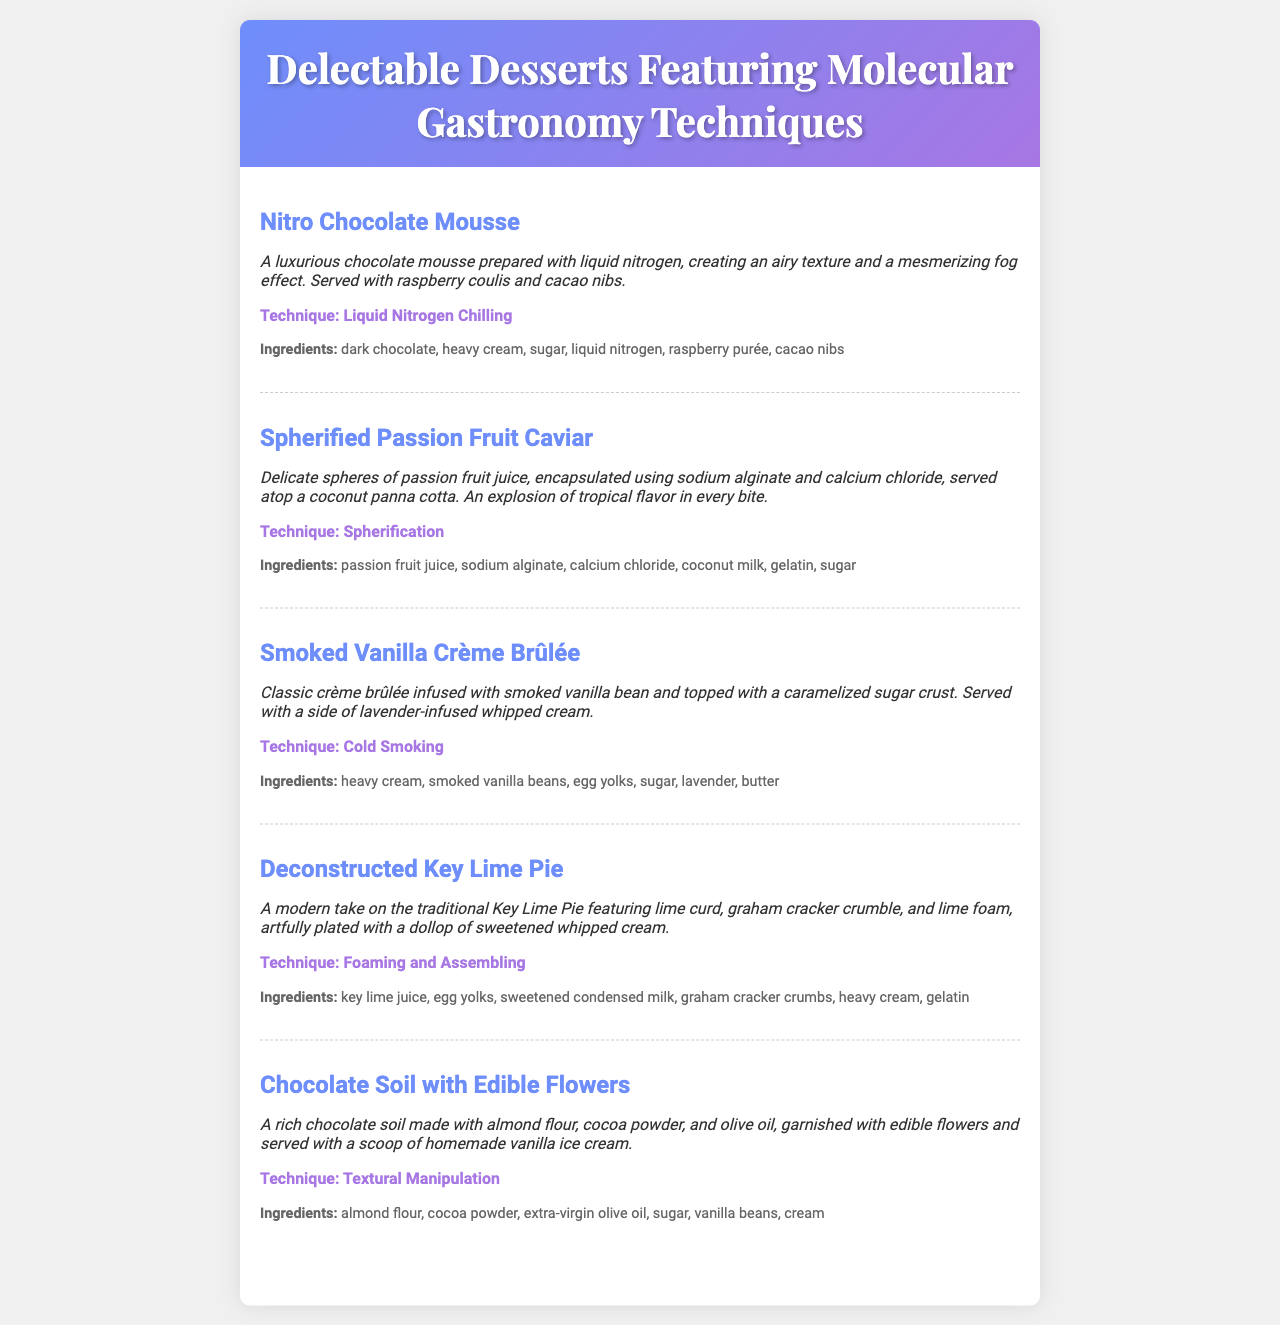What is the name of the first dessert on the menu? The first dessert listed in the menu is "Nitro Chocolate Mousse."
Answer: Nitro Chocolate Mousse What technique is used in the Spherified Passion Fruit Caviar? The technique applied in this dessert is "Spherification."
Answer: Spherification Which ingredient is not used in the Smoked Vanilla Crème Brûlée? The ingredient not mentioned is "sodium alginate."
Answer: sodium alginate What is the primary fruit used in the Deconstructed Key Lime Pie? The main fruit highlighted in this dessert is "lime."
Answer: lime How many desserts feature a technique related to "Chilling"? Only one dessert employs a chilling technique, which is "Nitro Chocolate Mousse."
Answer: 1 What unique aspect does the Chocolate Soil with Edible Flowers incorporate? The dessert uniquely incorporates "edible flowers."
Answer: edible flowers What type of cuisine does the document focus on? The overall cuisine style presented in the document is "Molecular Gastronomy."
Answer: Molecular Gastronomy What element enhances the flavor of the Vanilla Crème Brûlée? The flavor enhancement in the dessert comes from "smoked vanilla bean."
Answer: smoked vanilla bean 